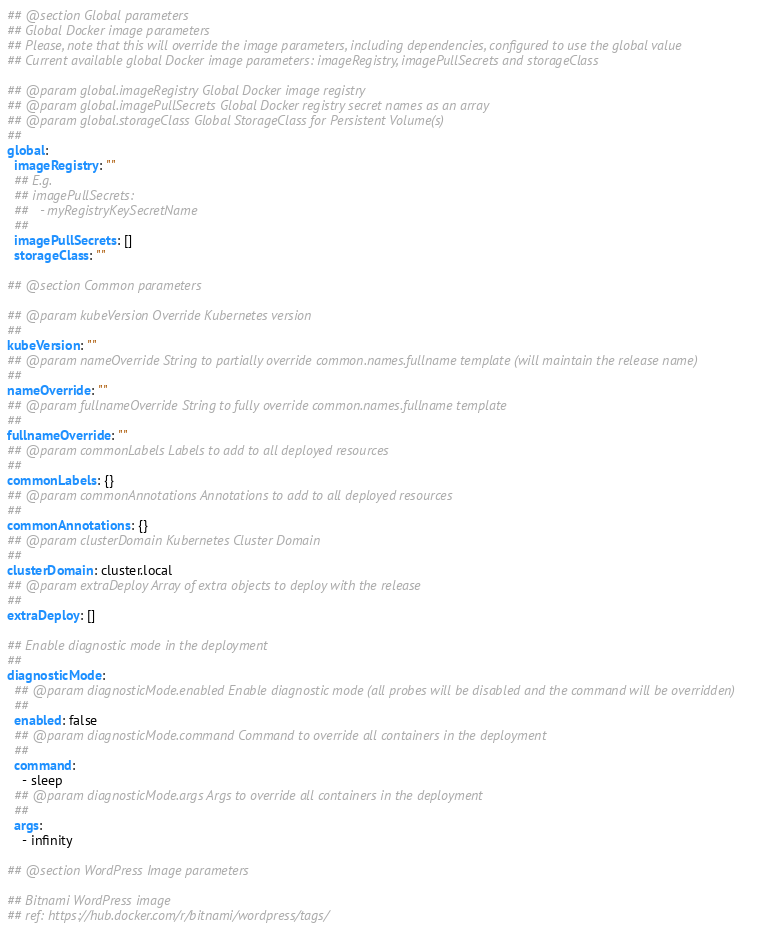<code> <loc_0><loc_0><loc_500><loc_500><_YAML_>## @section Global parameters
## Global Docker image parameters
## Please, note that this will override the image parameters, including dependencies, configured to use the global value
## Current available global Docker image parameters: imageRegistry, imagePullSecrets and storageClass

## @param global.imageRegistry Global Docker image registry
## @param global.imagePullSecrets Global Docker registry secret names as an array
## @param global.storageClass Global StorageClass for Persistent Volume(s)
##
global:
  imageRegistry: ""
  ## E.g.
  ## imagePullSecrets:
  ##   - myRegistryKeySecretName
  ##
  imagePullSecrets: []
  storageClass: ""

## @section Common parameters

## @param kubeVersion Override Kubernetes version
##
kubeVersion: ""
## @param nameOverride String to partially override common.names.fullname template (will maintain the release name)
##
nameOverride: ""
## @param fullnameOverride String to fully override common.names.fullname template
##
fullnameOverride: ""
## @param commonLabels Labels to add to all deployed resources
##
commonLabels: {}
## @param commonAnnotations Annotations to add to all deployed resources
##
commonAnnotations: {}
## @param clusterDomain Kubernetes Cluster Domain
##
clusterDomain: cluster.local
## @param extraDeploy Array of extra objects to deploy with the release
##
extraDeploy: []

## Enable diagnostic mode in the deployment
##
diagnosticMode:
  ## @param diagnosticMode.enabled Enable diagnostic mode (all probes will be disabled and the command will be overridden)
  ##
  enabled: false
  ## @param diagnosticMode.command Command to override all containers in the deployment
  ##
  command:
    - sleep
  ## @param diagnosticMode.args Args to override all containers in the deployment
  ##
  args:
    - infinity

## @section WordPress Image parameters

## Bitnami WordPress image
## ref: https://hub.docker.com/r/bitnami/wordpress/tags/</code> 